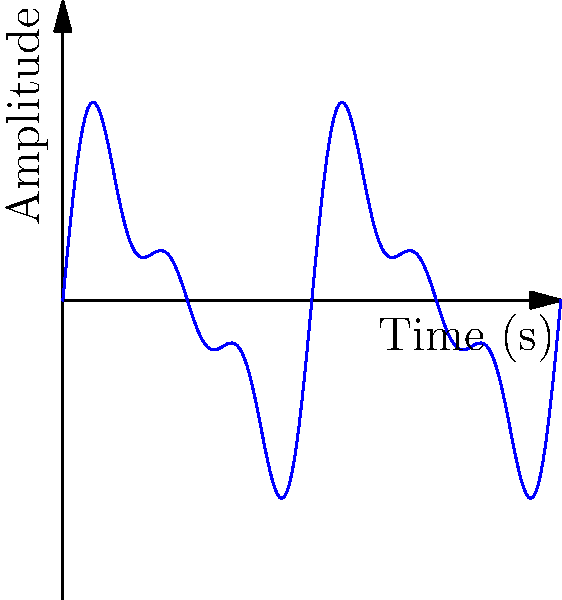The graph above represents the sound wave of a traditional Irish fiddle playing a complex note. The amplitude $A$ of the wave at time $t$ seconds is given by the polynomial function:

$A(t) = 0.5\sin(2\pi t) + 0.3\sin(4\pi t) + 0.2\sin(6\pi t)$

What is the degree of this polynomial function, and what does it tell us about the complexity of the sound? To determine the degree of this polynomial function and understand its implications for the sound's complexity, let's follow these steps:

1) First, we need to recognize that this is not a standard polynomial function, but a trigonometric polynomial. The degree of a trigonometric polynomial is determined by the highest multiple of the fundamental frequency.

2) In this case, we have three terms:
   - $0.5\sin(2\pi t)$: fundamental frequency (1st harmonic)
   - $0.3\sin(4\pi t)$: 2nd harmonic
   - $0.2\sin(6\pi t)$: 3rd harmonic

3) The highest multiple of the fundamental frequency $(2\pi)$ is $6\pi$, which appears in the third term.

4) Therefore, the degree of this trigonometric polynomial is 3.

5) In terms of sound complexity, each term in the function represents a different harmonic or overtone in the sound:
   - The first term is the fundamental tone
   - The second term is the first overtone (an octave above the fundamental)
   - The third term is the second overtone

6) Having three terms means that this sound wave includes the fundamental tone and two overtones, creating a rich, complex timbre characteristic of traditional Irish fiddle music.

7) The coefficients (0.5, 0.3, 0.2) represent the relative strengths of each harmonic, with the fundamental being the strongest and the overtones progressively weaker.
Answer: Degree 3; indicates presence of fundamental tone and two overtones, creating a complex timbre. 